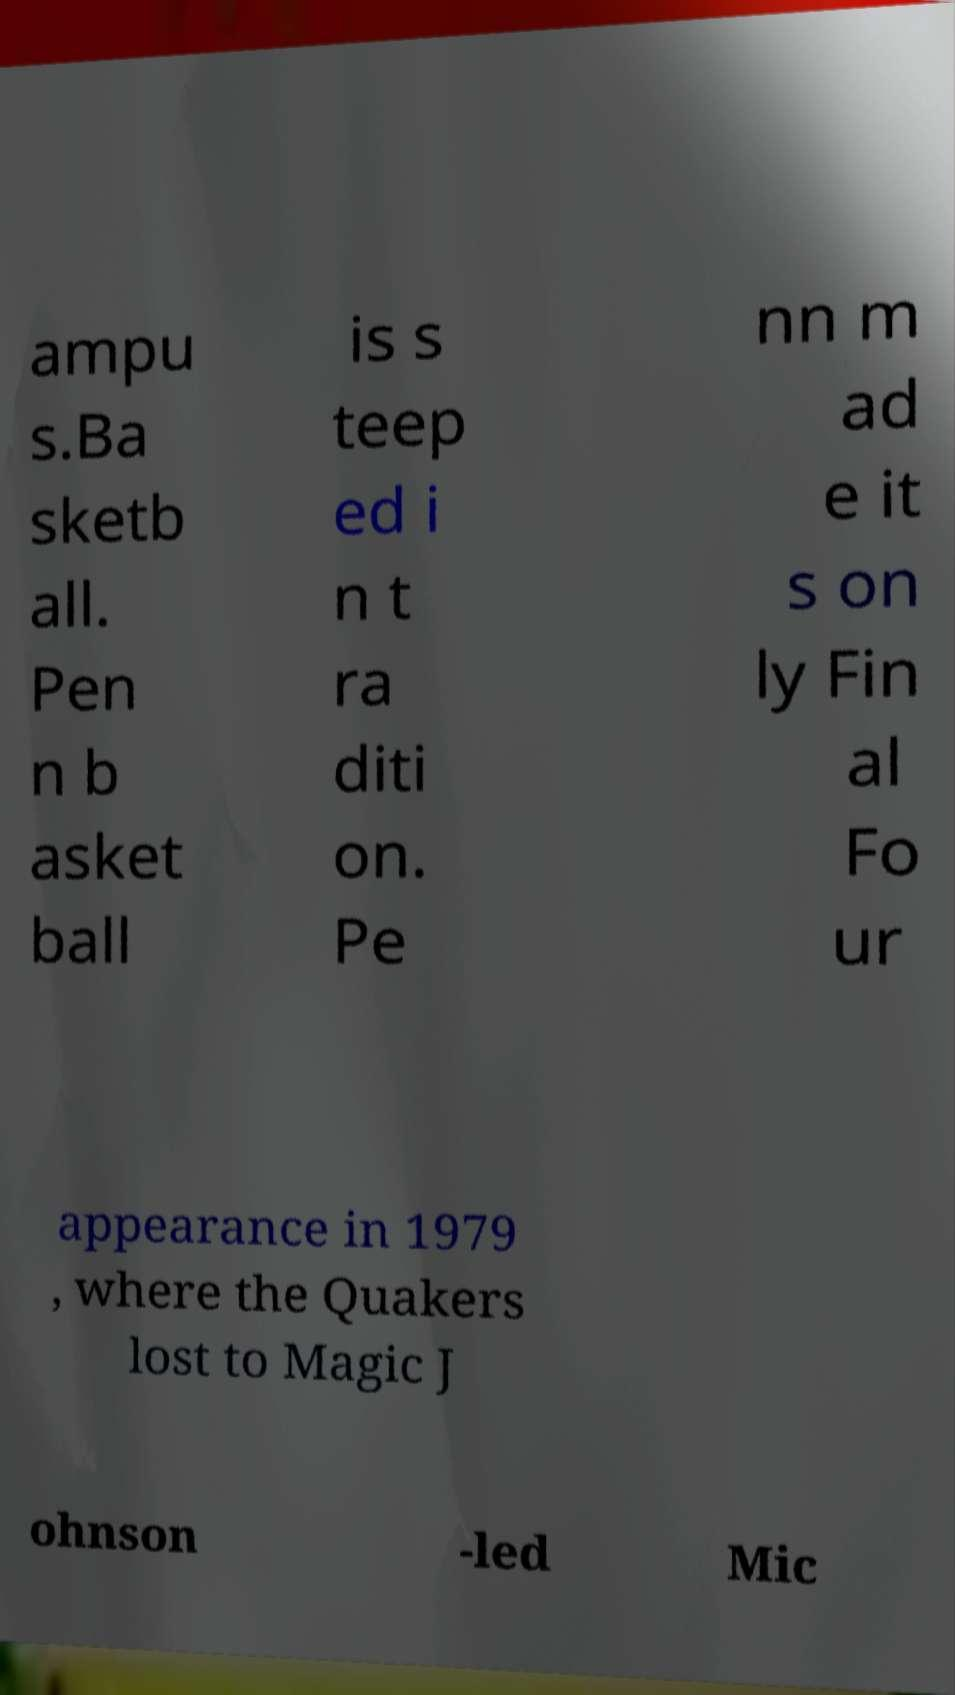Could you extract and type out the text from this image? ampu s.Ba sketb all. Pen n b asket ball is s teep ed i n t ra diti on. Pe nn m ad e it s on ly Fin al Fo ur appearance in 1979 , where the Quakers lost to Magic J ohnson -led Mic 